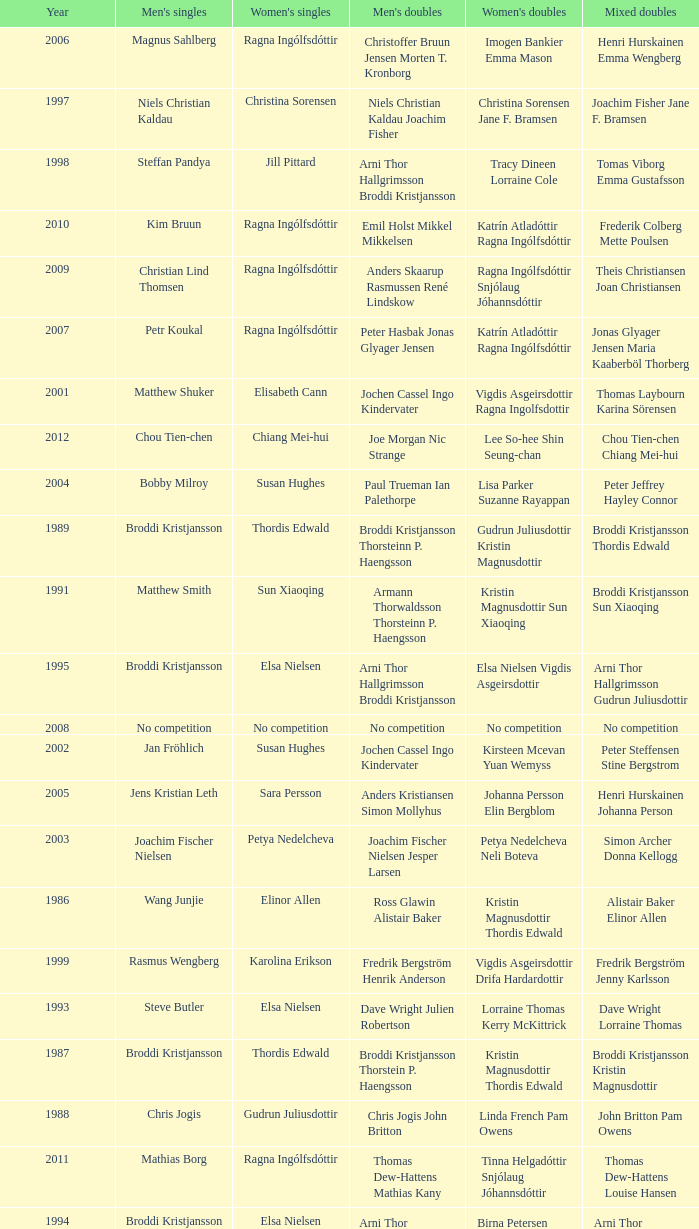In what mixed doubles did Niels Christian Kaldau play in men's singles? Joachim Fisher Jane F. Bramsen. 